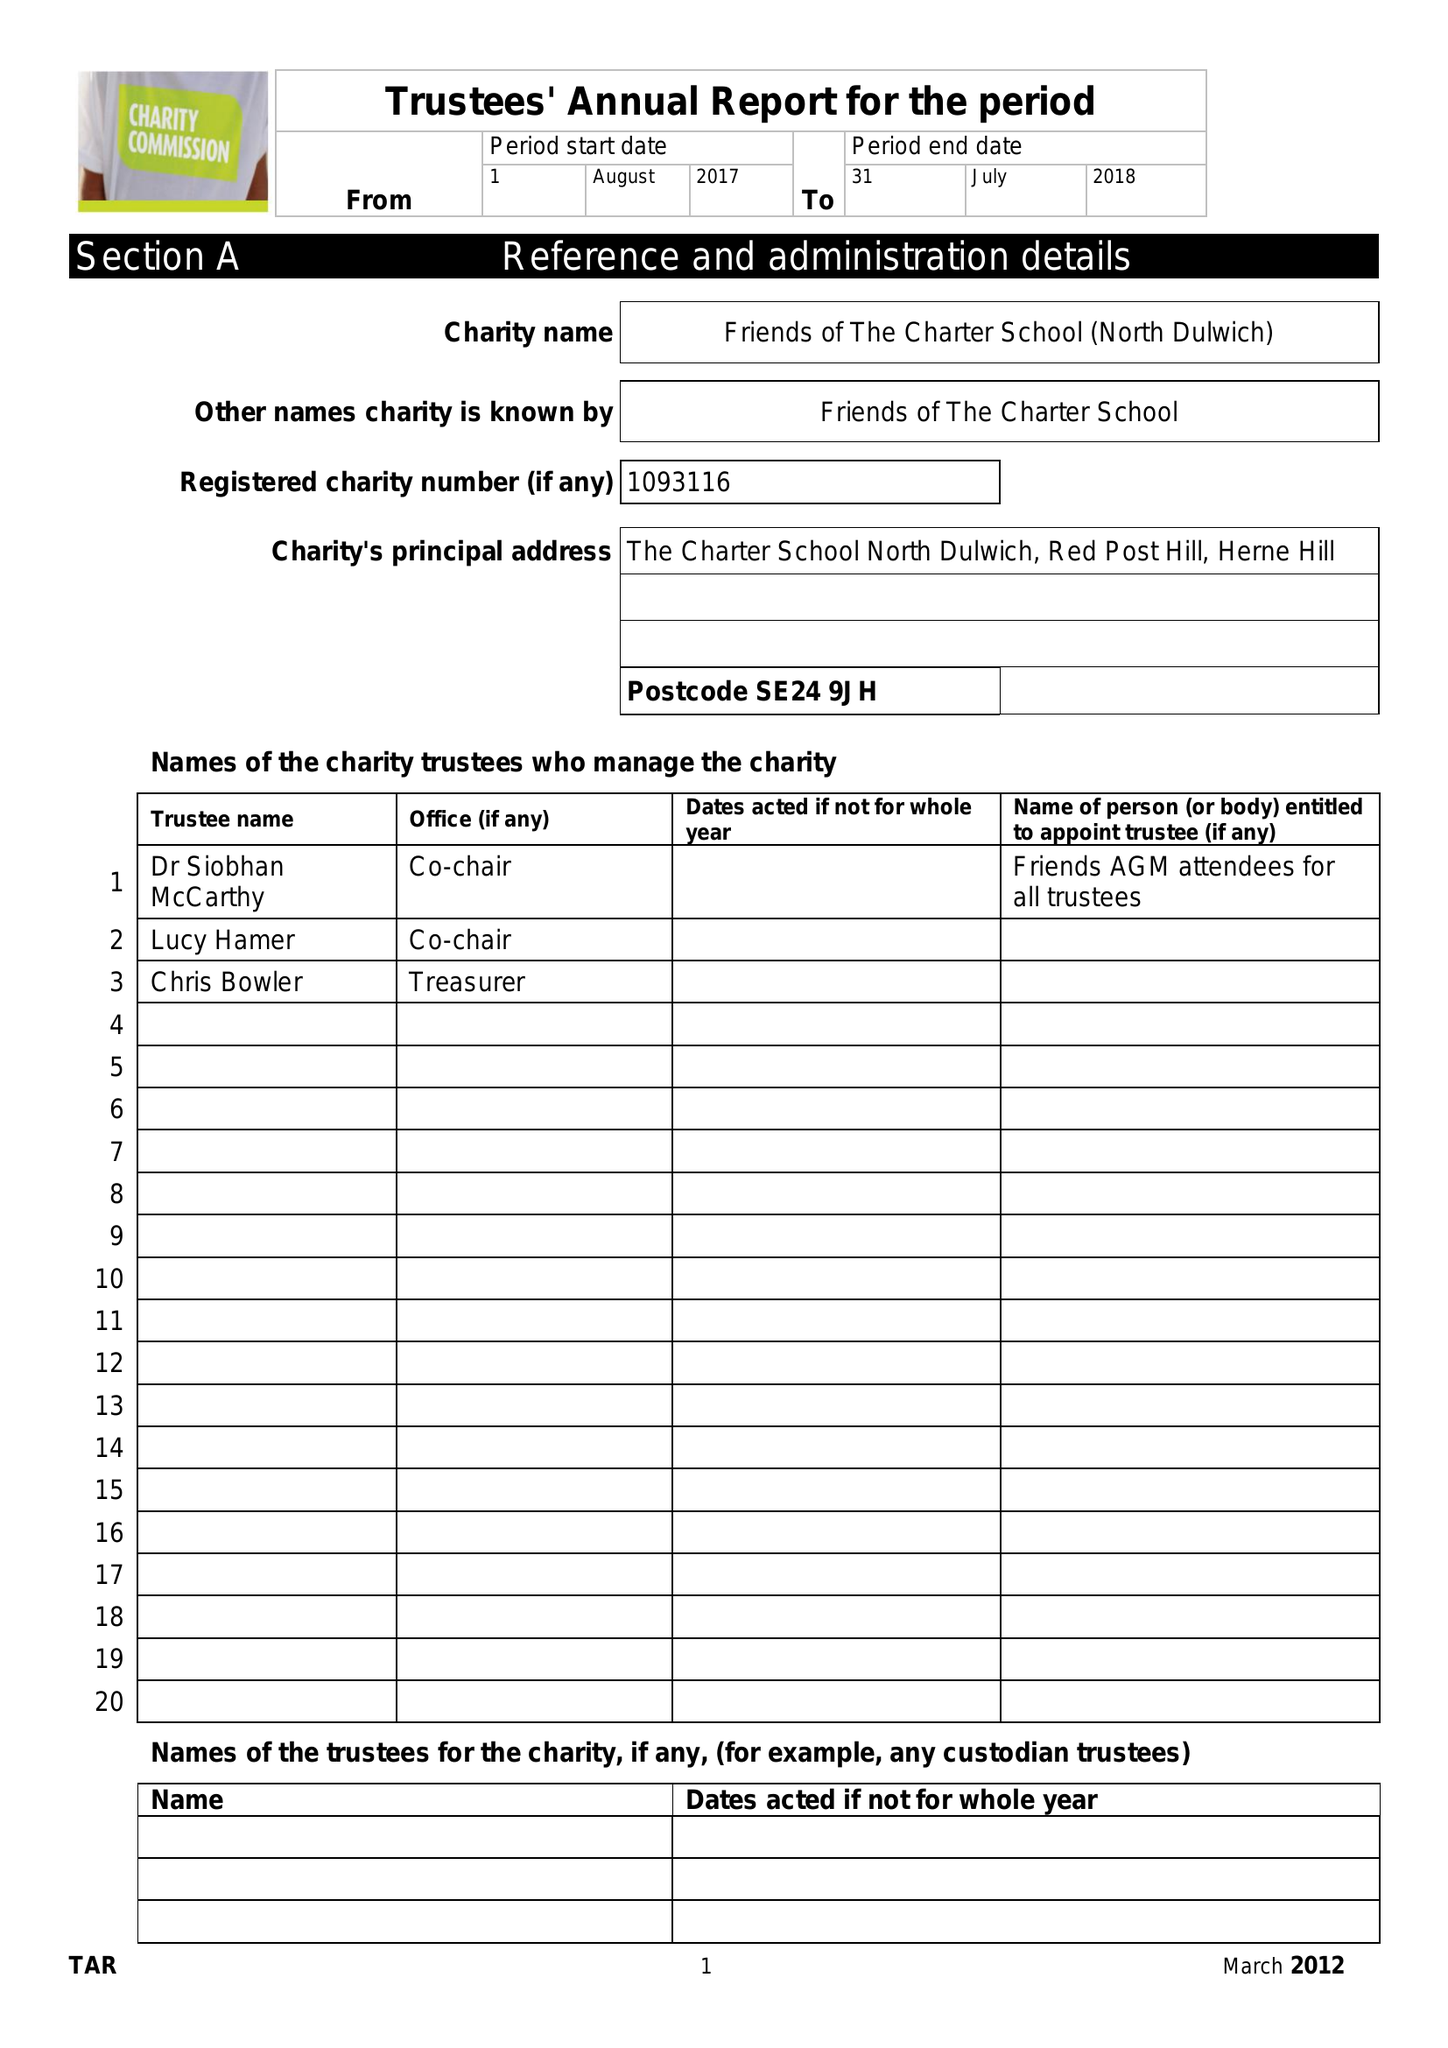What is the value for the report_date?
Answer the question using a single word or phrase. 2018-07-31 